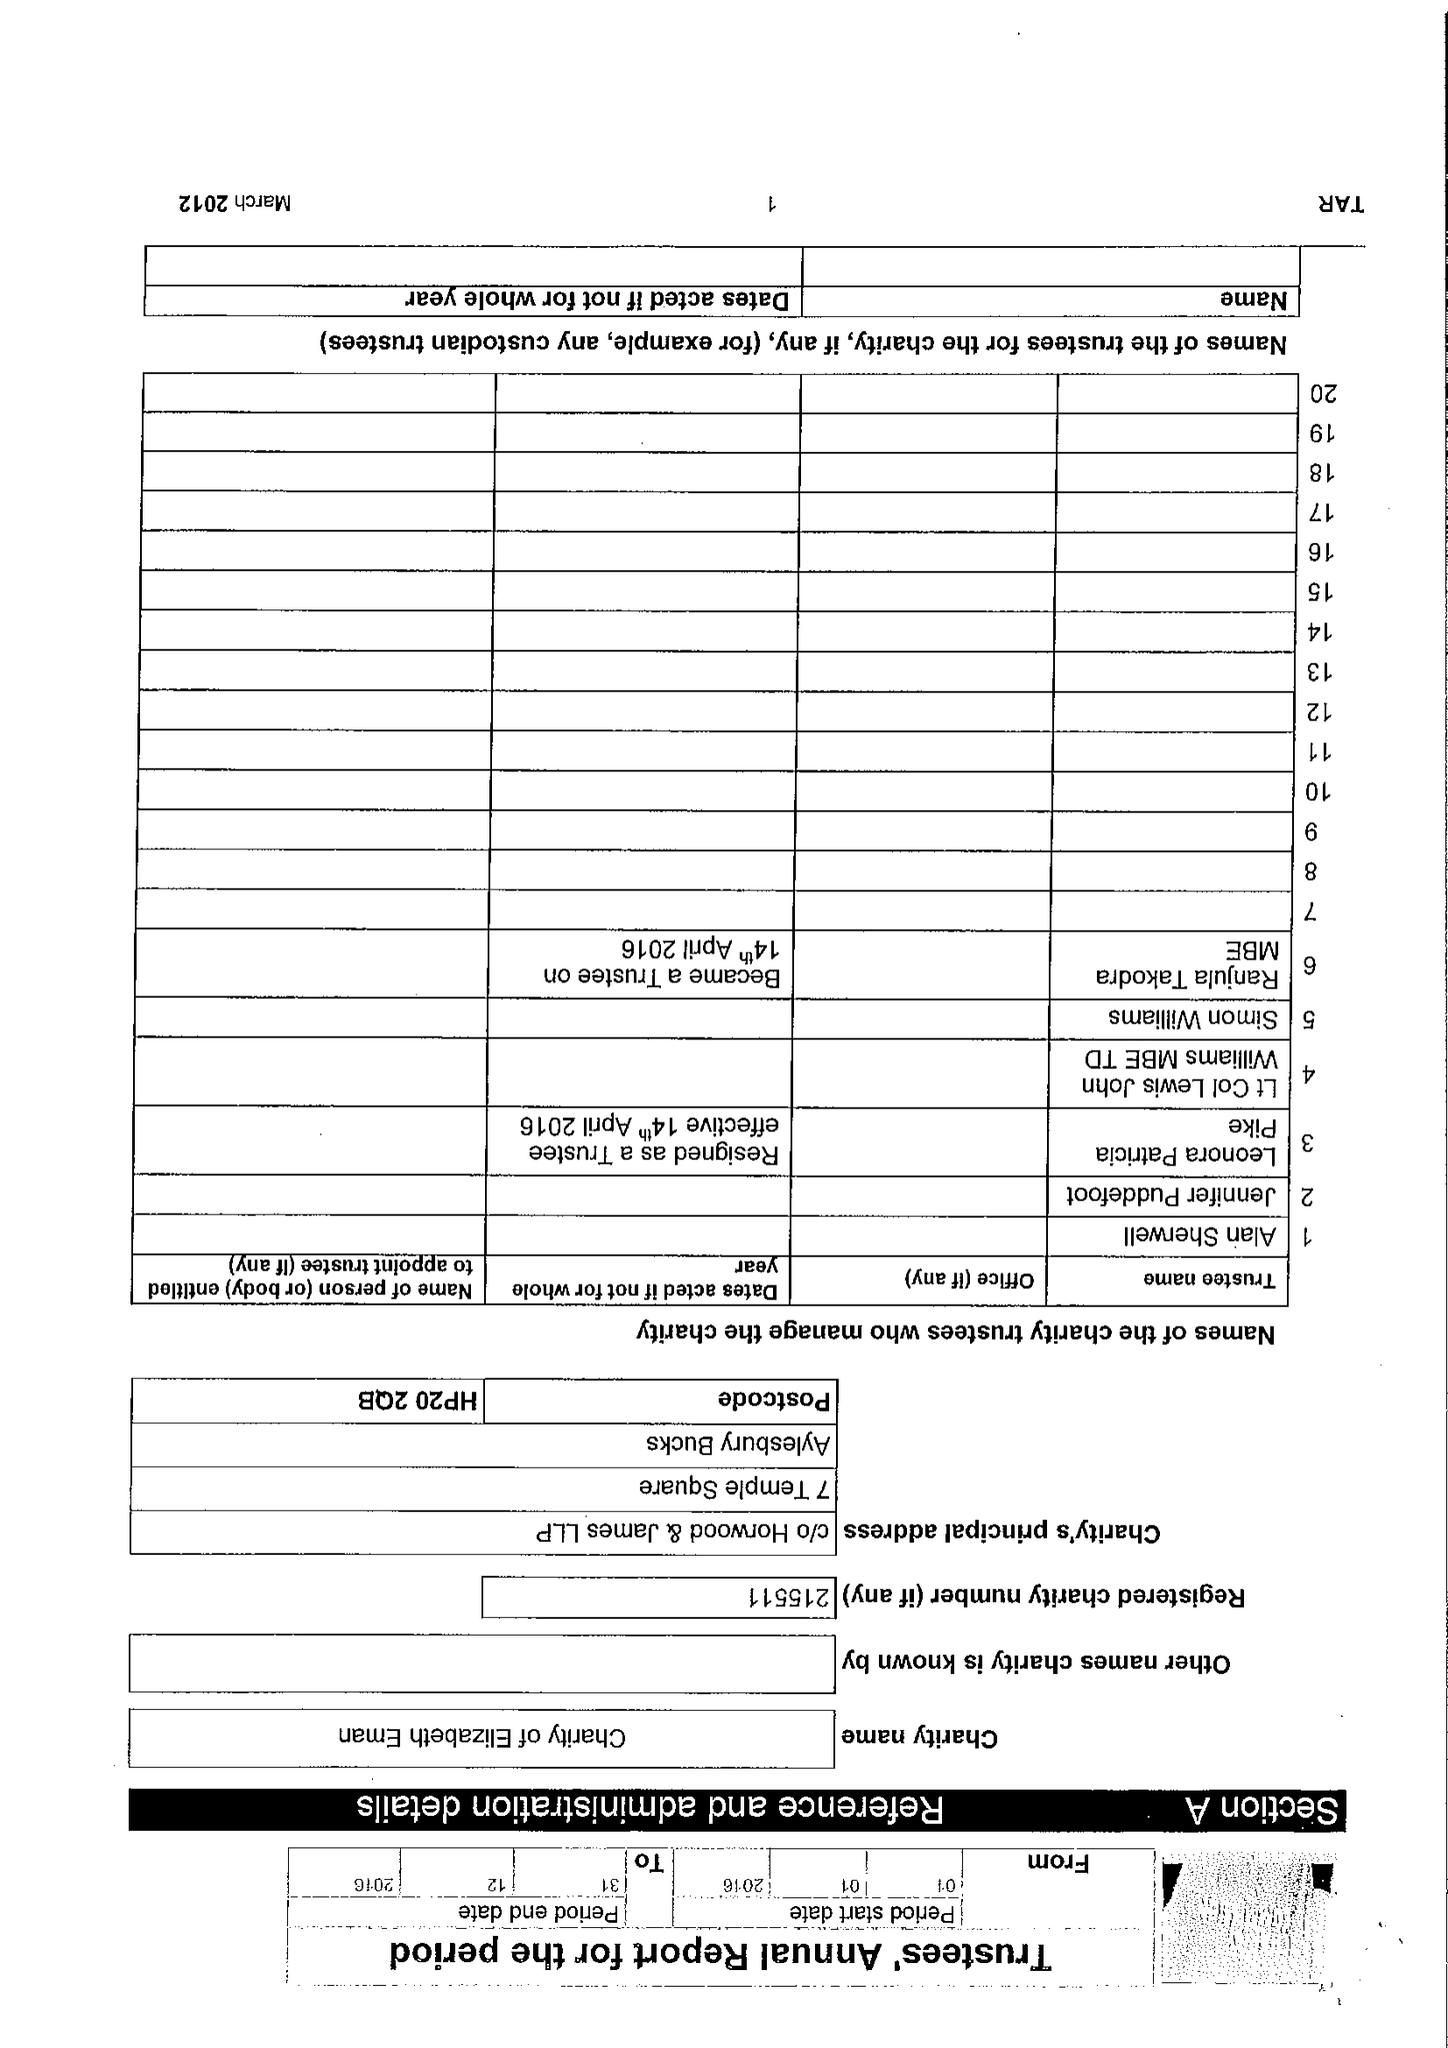What is the value for the income_annually_in_british_pounds?
Answer the question using a single word or phrase. 60415.00 